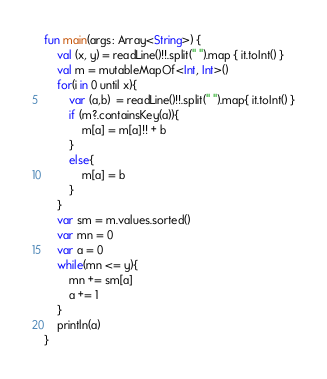Convert code to text. <code><loc_0><loc_0><loc_500><loc_500><_Kotlin_>fun main(args: Array<String>) {
    val (x, y) = readLine()!!.split(" ").map { it.toInt() }
    val m = mutableMapOf<Int, Int>()
    for(i in 0 until x){
        var (a,b)  = readLine()!!.split(" ").map{ it.toInt() }
        if (m?.containsKey(a)){
            m[a] = m[a]!! + b
        }
        else{
            m[a] = b
        }
    }
    var sm = m.values.sorted()
    var mn = 0
    var a = 0
    while(mn <= y){
        mn += sm[a]
        a += 1
    }
    println(a)
}</code> 